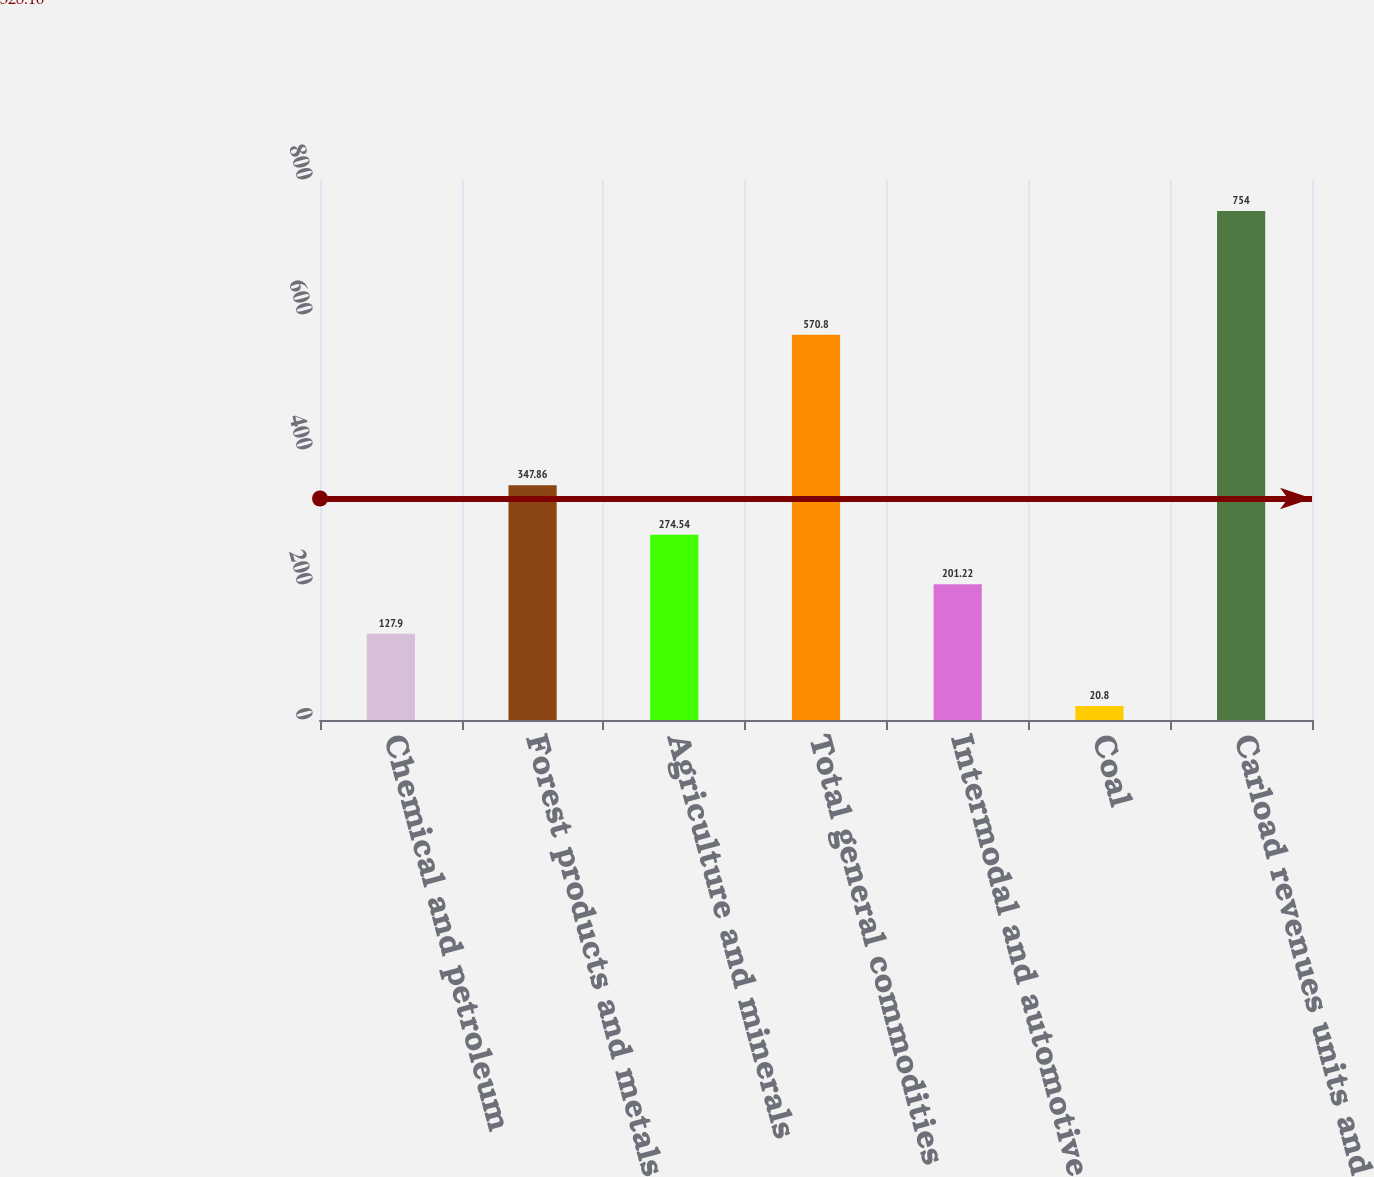Convert chart. <chart><loc_0><loc_0><loc_500><loc_500><bar_chart><fcel>Chemical and petroleum<fcel>Forest products and metals<fcel>Agriculture and minerals<fcel>Total general commodities<fcel>Intermodal and automotive<fcel>Coal<fcel>Carload revenues units and<nl><fcel>127.9<fcel>347.86<fcel>274.54<fcel>570.8<fcel>201.22<fcel>20.8<fcel>754<nl></chart> 